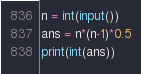Convert code to text. <code><loc_0><loc_0><loc_500><loc_500><_Python_>n = int(input())
ans = n*(n-1)*0.5
print(int(ans))</code> 